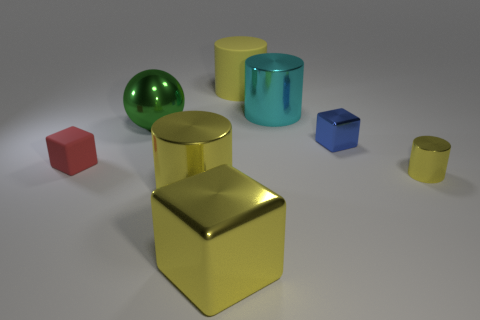Subtract all yellow cylinders. How many were subtracted if there are1yellow cylinders left? 2 Add 1 purple metal cylinders. How many objects exist? 9 Subtract all tiny blocks. How many blocks are left? 1 Add 4 small red rubber objects. How many small red rubber objects exist? 5 Subtract all red cubes. How many cubes are left? 2 Subtract 0 green cubes. How many objects are left? 8 Subtract all spheres. How many objects are left? 7 Subtract 2 blocks. How many blocks are left? 1 Subtract all blue cylinders. Subtract all gray balls. How many cylinders are left? 4 Subtract all cyan cubes. How many blue balls are left? 0 